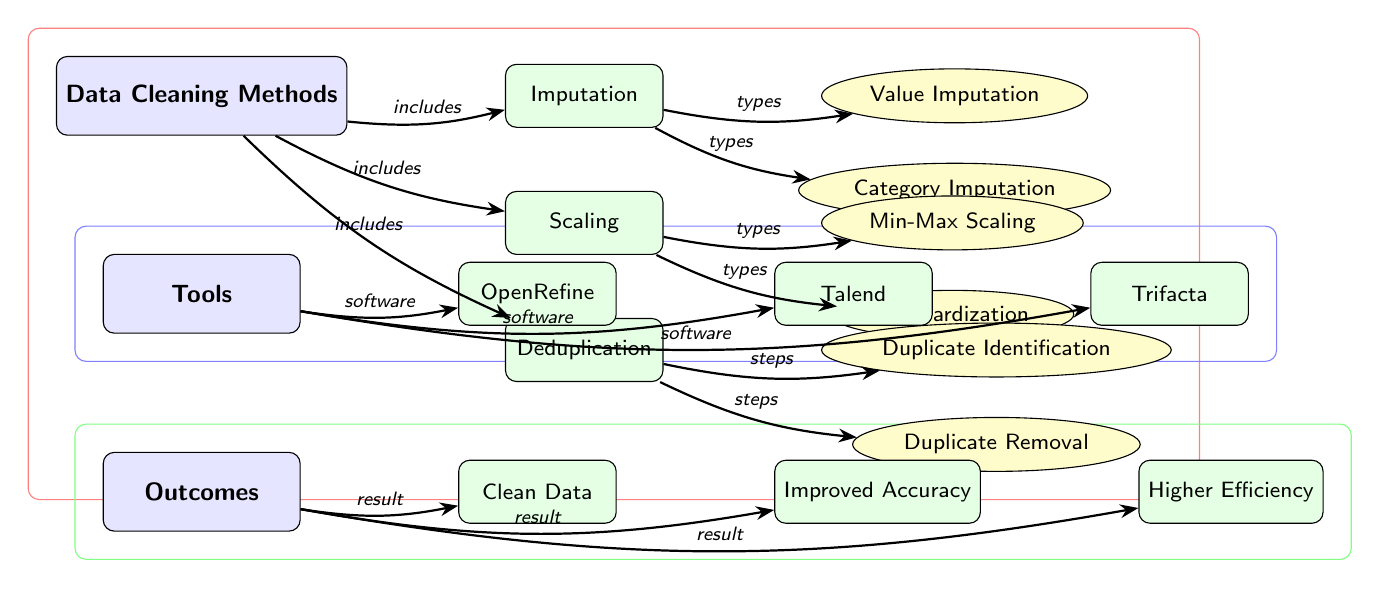What are the three main data cleaning methods? The diagram shows three main nodes under Data Cleaning Methods: Imputation, Scaling, and Deduplication.
Answer: Imputation, Scaling, Deduplication How many types of imputation are listed in the diagram? The diagram includes two leaf nodes under Imputation: Value Imputation and Category Imputation, resulting in a total of two types.
Answer: 2 Which tool is found directly to the right of OpenRefine? The diagram showcases a series of nodes under Tools, with Talend positioned directly to the right of OpenRefine.
Answer: Talend What is the outcome associated with the result of improved accuracy? In the Outcomes section, Improved Accuracy is listed as one of the results, showing a direct connection to the Outcomes node.
Answer: Improved Accuracy What type of scaling is represented in the diagram? The Scaling node has two types represented as leaf nodes: Min-Max Scaling and Standardization, making them the specific types of scaling depicted.
Answer: Min-Max Scaling, Standardization Which data cleaning method includes the steps of identification and removal? The Deduplication node in the diagram clearly lists Identification and Removal as its associated steps, showing the clear relationship between these methods.
Answer: Deduplication How many nodes connect to the main Outcomes node? From the Outcomes node, there are three leaf nodes connected: Clean Data, Improved Accuracy, and Higher Efficiency, indicating three separate outcomes arising from the data cleaning process.
Answer: 3 Which rectangular area is colored red in the background of the diagram? The red rectangular area encompasses the main nodes under Data Cleaning Methods, highlighting that this area is focused on the different methods of data cleaning techniques.
Answer: Data Cleaning Methods 